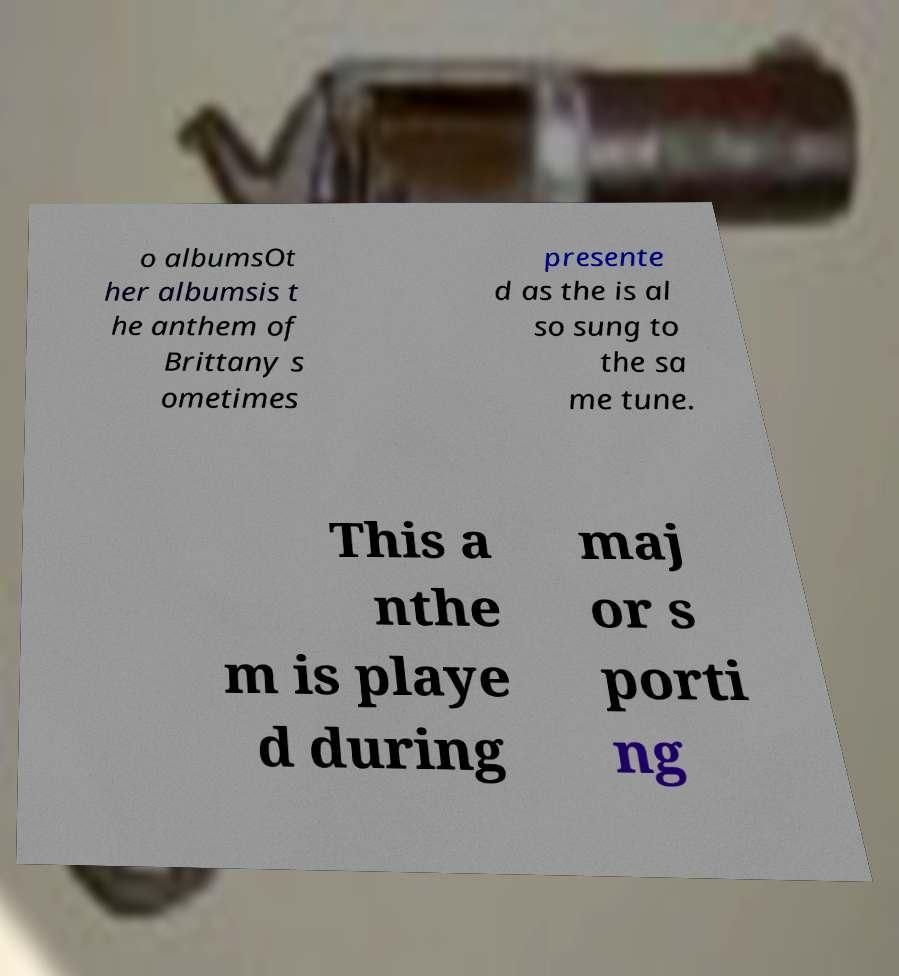Please read and relay the text visible in this image. What does it say? o albumsOt her albumsis t he anthem of Brittany s ometimes presente d as the is al so sung to the sa me tune. This a nthe m is playe d during maj or s porti ng 